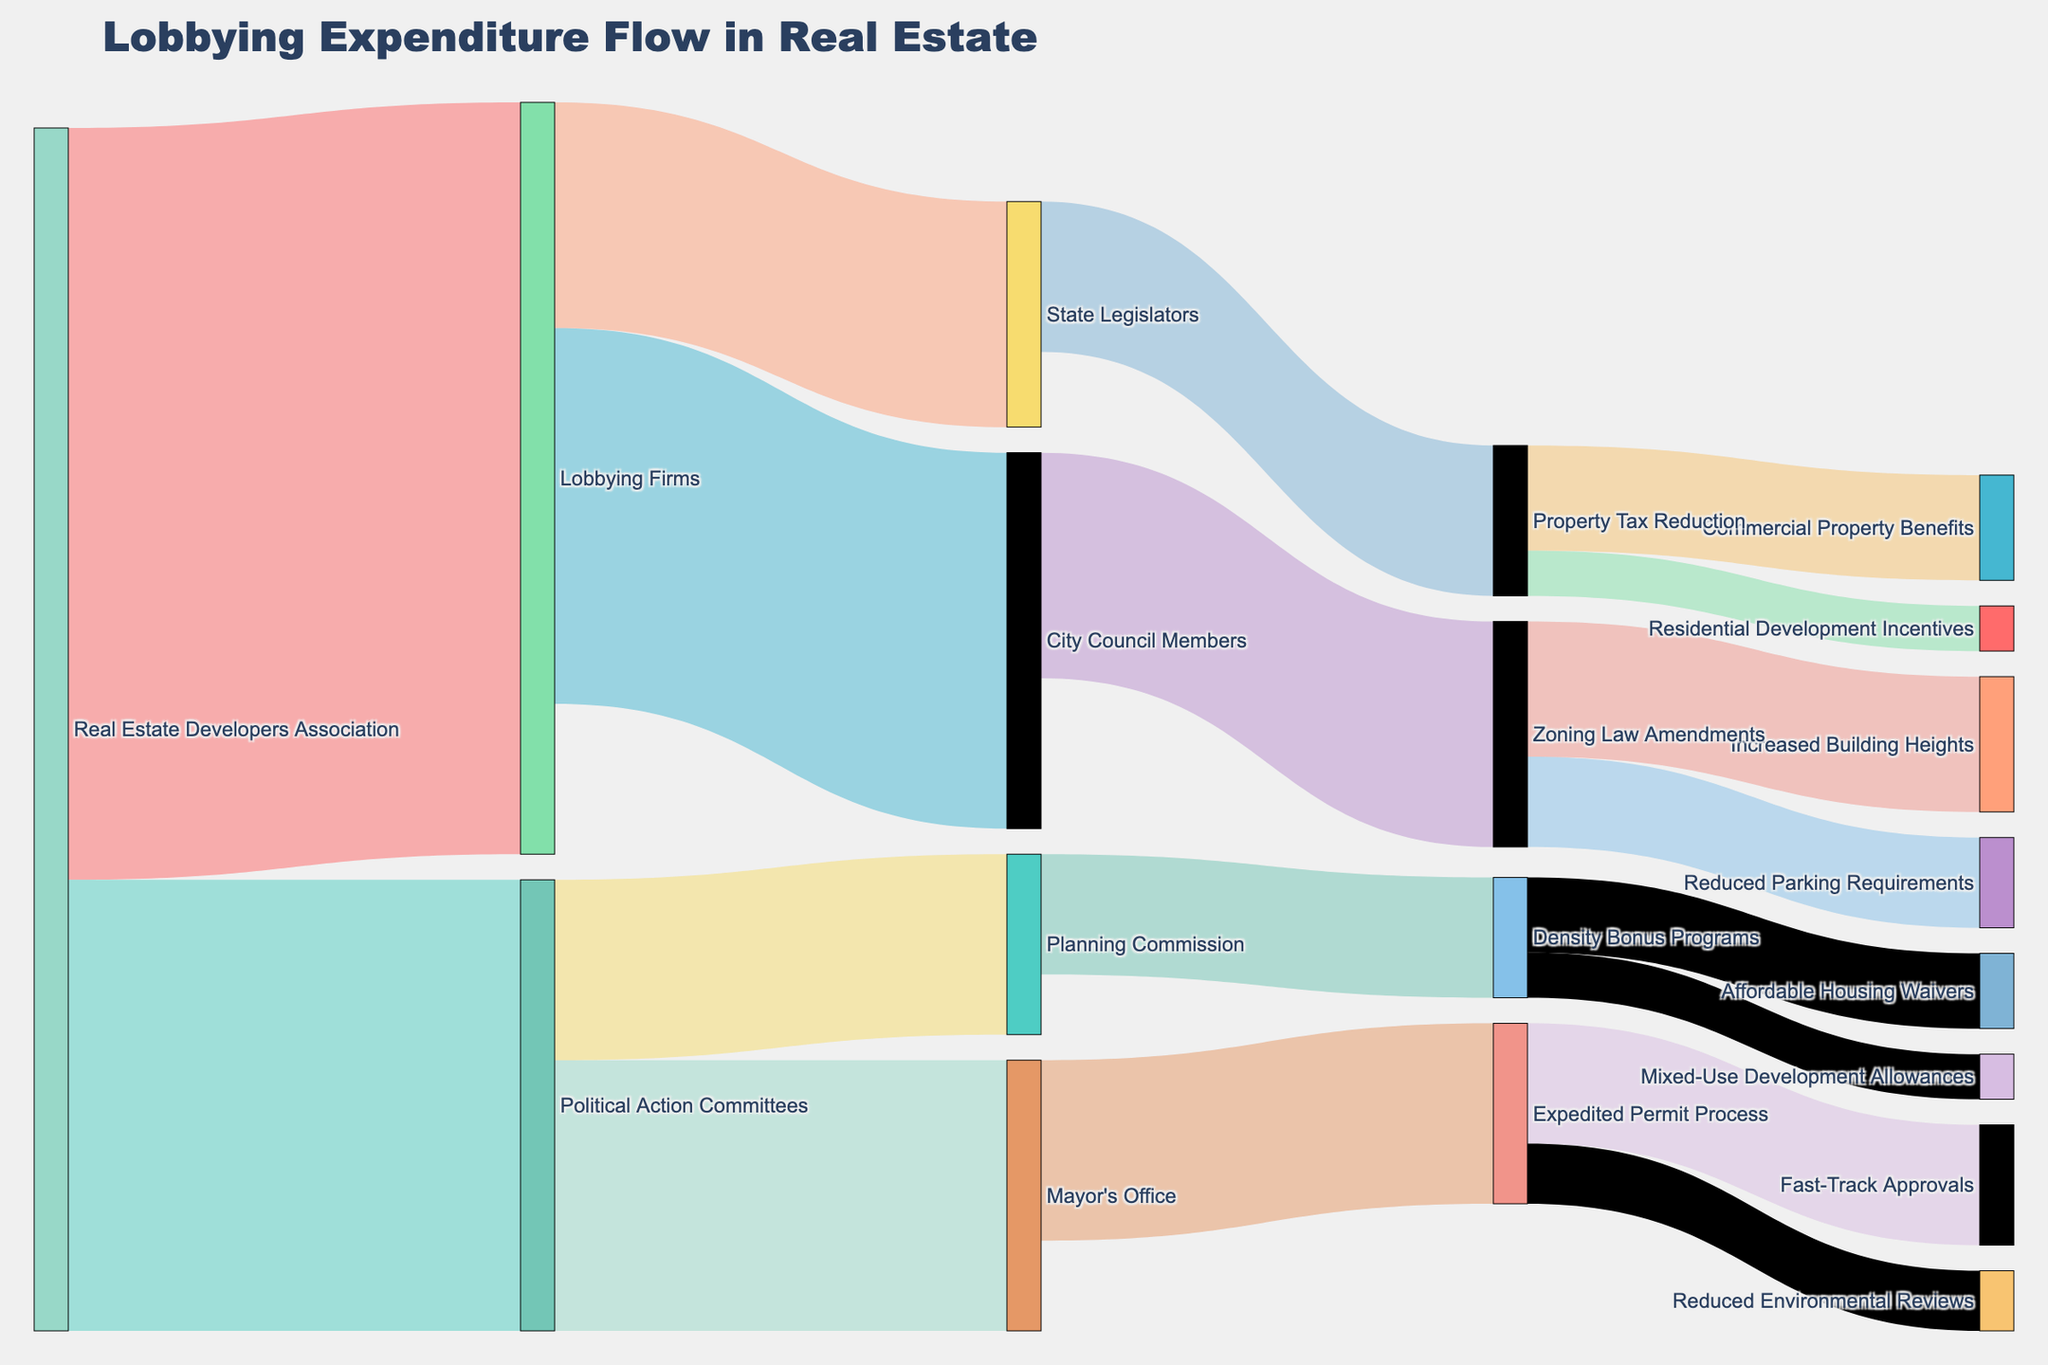What is the title of the Sankey Diagram? The title of the figure is directly indicated at the top of the diagram in bold and large font.
Answer: Lobbying Expenditure Flow in Real Estate Which entity channels the highest amount of funds, and how much is it? Look for the largest value linked from any entity. The "Real Estate Developers Association" channels the highest amount of funds, which is $5,000,000 to "Lobbying Firms."
Answer: Real Estate Developers Association, $5,000,000 What is the total amount of funds channeled by the Real Estate Developers Association? Add the values of the flows stemming from "Real Estate Developers Association," which are $5,000,000 and $3,000,000.
Answer: $8,000,000 How much money does the Mayor's Office receive and from which sources? Check incoming links to "Mayor's Office," which indicates $1,800,000 from "Political Action Committees."
Answer: $1,800,000 from Political Action Committees Which entity receives funds specifically for zoning law amendments? Identify the flow directed at "Zoning Law Amendments." "City Council Members" channels $1,500,000 to it.
Answer: City Council Members What are the expenditures of the Planning Commission? Observe the outgoing links from Planning Commission, which are $500,000 for Affordable Housing Waivers and $300,000 for Mixed-Use Development Allowances.
Answer: $800,000 total Which initiatives result from the Expedited Permit Process and by how much? Identify the outcomes linked to "Expedited Permit Process," which includes "Fast-Track Approvals" with $800,000 and "Reduced Environmental Reviews" with $400,000.
Answer: Fast-Track Approvals, $800,000; Reduced Environmental Reviews, $400,000 How much total funding does "Political Action Committees" distribute, and to which entities? Sum the outgoing links from "Political Action Committees," which are $1,800,000 to "Mayor's Office" and $1,200,000 to "Planning Commission."
Answer: $3,000,000, Mayor's Office and Planning Commission Which entity has the least amount of outgoing funding and what is it? Compare the total outgoing funds from all entities; "Density Bonus Programs" has two outflows of $500,000 and $300,000, totaling $800,000.
Answer: Density Bonus Programs, $800,000 